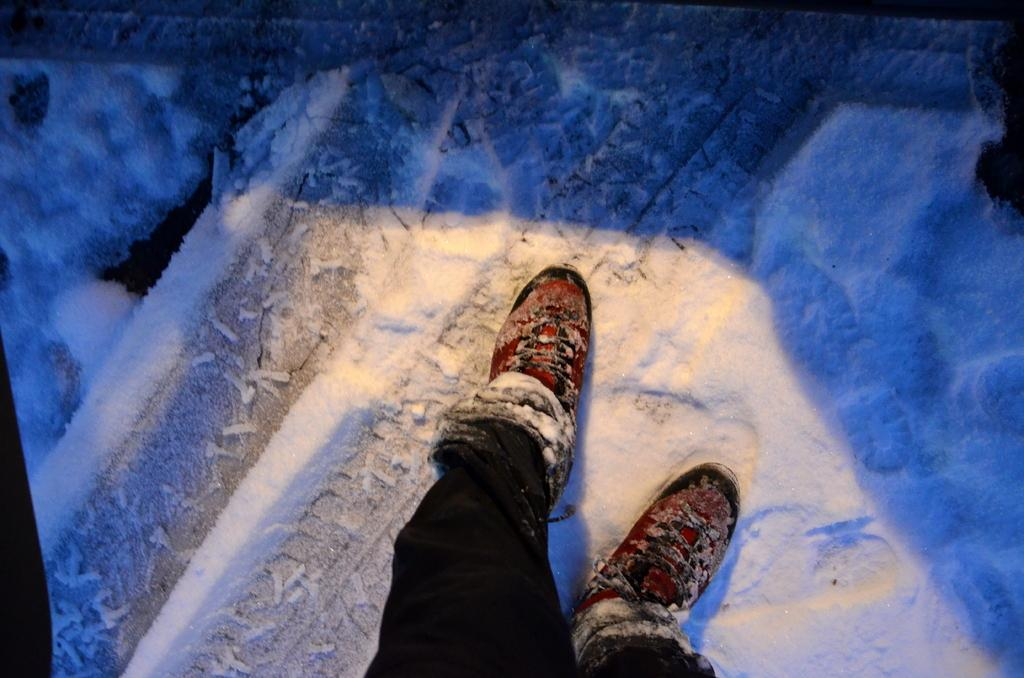What body parts are visible in the image? Human legs are visible in the image. What are the legs wearing? The legs are wearing clothes and shoes. What is the environment like in the image? The image shows a snowy environment. What is the color of the snow in the image? The snow is white in color. Where is the watch located in the image? There is no watch present in the image. What type of nest can be seen in the image? There is no nest present in the image. 